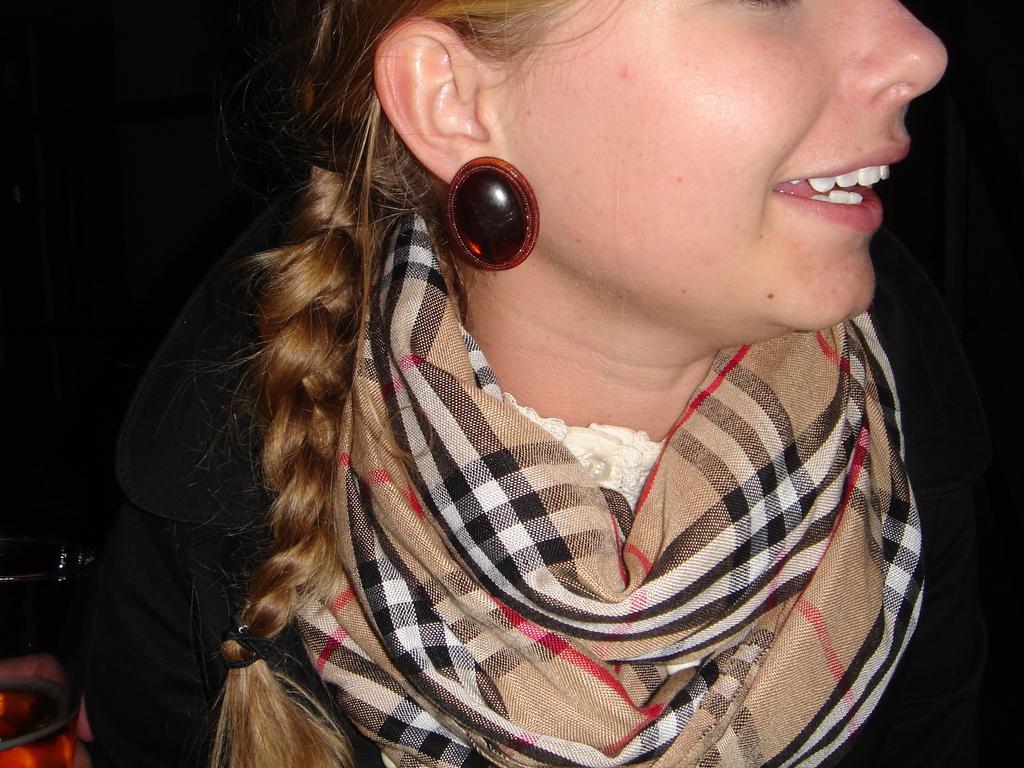How would you summarize this image in a sentence or two? In this image I can see a person and the person is wearing cream and black color scarf and black color shirt and I can see dark background. 